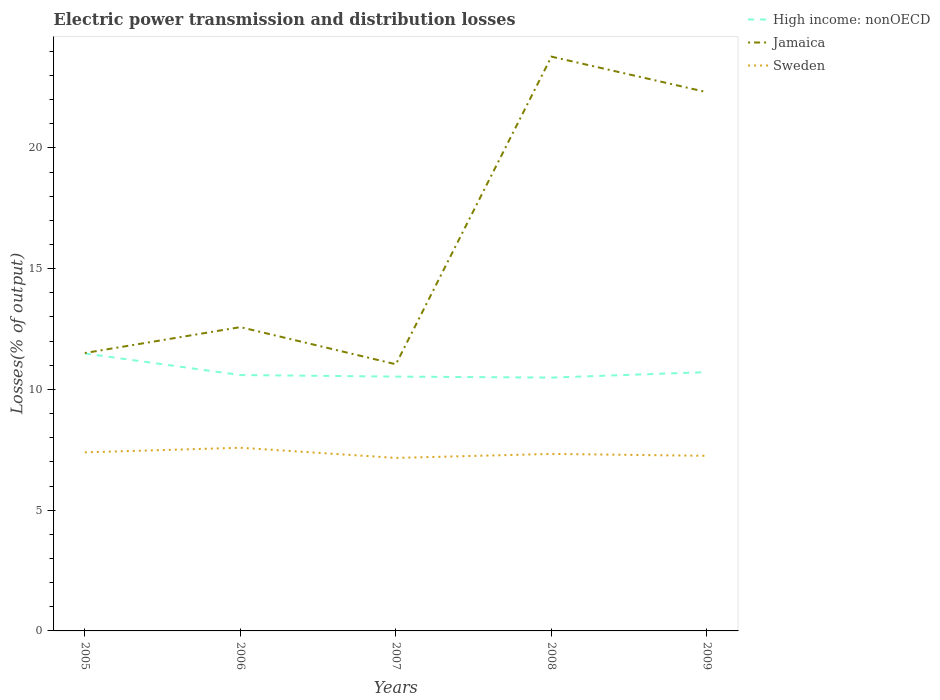How many different coloured lines are there?
Offer a terse response. 3. Across all years, what is the maximum electric power transmission and distribution losses in Sweden?
Provide a short and direct response. 7.16. In which year was the electric power transmission and distribution losses in Sweden maximum?
Provide a succinct answer. 2007. What is the total electric power transmission and distribution losses in Jamaica in the graph?
Give a very brief answer. -9.73. What is the difference between the highest and the second highest electric power transmission and distribution losses in Jamaica?
Offer a very short reply. 12.74. What is the difference between the highest and the lowest electric power transmission and distribution losses in Jamaica?
Your answer should be very brief. 2. Is the electric power transmission and distribution losses in High income: nonOECD strictly greater than the electric power transmission and distribution losses in Jamaica over the years?
Your answer should be compact. Yes. How many lines are there?
Offer a terse response. 3. What is the difference between two consecutive major ticks on the Y-axis?
Give a very brief answer. 5. Are the values on the major ticks of Y-axis written in scientific E-notation?
Offer a terse response. No. Does the graph contain any zero values?
Your answer should be very brief. No. What is the title of the graph?
Your answer should be very brief. Electric power transmission and distribution losses. What is the label or title of the X-axis?
Provide a succinct answer. Years. What is the label or title of the Y-axis?
Offer a very short reply. Losses(% of output). What is the Losses(% of output) of High income: nonOECD in 2005?
Your answer should be compact. 11.49. What is the Losses(% of output) in Jamaica in 2005?
Your answer should be very brief. 11.51. What is the Losses(% of output) of Sweden in 2005?
Ensure brevity in your answer.  7.39. What is the Losses(% of output) of High income: nonOECD in 2006?
Make the answer very short. 10.59. What is the Losses(% of output) of Jamaica in 2006?
Keep it short and to the point. 12.58. What is the Losses(% of output) in Sweden in 2006?
Provide a short and direct response. 7.58. What is the Losses(% of output) of High income: nonOECD in 2007?
Provide a short and direct response. 10.53. What is the Losses(% of output) in Jamaica in 2007?
Ensure brevity in your answer.  11.04. What is the Losses(% of output) in Sweden in 2007?
Provide a short and direct response. 7.16. What is the Losses(% of output) in High income: nonOECD in 2008?
Offer a terse response. 10.49. What is the Losses(% of output) of Jamaica in 2008?
Your answer should be very brief. 23.78. What is the Losses(% of output) of Sweden in 2008?
Provide a short and direct response. 7.33. What is the Losses(% of output) of High income: nonOECD in 2009?
Keep it short and to the point. 10.72. What is the Losses(% of output) of Jamaica in 2009?
Give a very brief answer. 22.31. What is the Losses(% of output) of Sweden in 2009?
Give a very brief answer. 7.25. Across all years, what is the maximum Losses(% of output) in High income: nonOECD?
Give a very brief answer. 11.49. Across all years, what is the maximum Losses(% of output) of Jamaica?
Your answer should be compact. 23.78. Across all years, what is the maximum Losses(% of output) in Sweden?
Make the answer very short. 7.58. Across all years, what is the minimum Losses(% of output) of High income: nonOECD?
Your answer should be compact. 10.49. Across all years, what is the minimum Losses(% of output) of Jamaica?
Give a very brief answer. 11.04. Across all years, what is the minimum Losses(% of output) of Sweden?
Provide a short and direct response. 7.16. What is the total Losses(% of output) of High income: nonOECD in the graph?
Keep it short and to the point. 53.82. What is the total Losses(% of output) in Jamaica in the graph?
Give a very brief answer. 81.21. What is the total Losses(% of output) in Sweden in the graph?
Ensure brevity in your answer.  36.72. What is the difference between the Losses(% of output) in High income: nonOECD in 2005 and that in 2006?
Give a very brief answer. 0.89. What is the difference between the Losses(% of output) in Jamaica in 2005 and that in 2006?
Your answer should be very brief. -1.07. What is the difference between the Losses(% of output) in Sweden in 2005 and that in 2006?
Offer a terse response. -0.19. What is the difference between the Losses(% of output) in High income: nonOECD in 2005 and that in 2007?
Your response must be concise. 0.96. What is the difference between the Losses(% of output) of Jamaica in 2005 and that in 2007?
Give a very brief answer. 0.47. What is the difference between the Losses(% of output) of Sweden in 2005 and that in 2007?
Give a very brief answer. 0.23. What is the difference between the Losses(% of output) in Jamaica in 2005 and that in 2008?
Ensure brevity in your answer.  -12.27. What is the difference between the Losses(% of output) in Sweden in 2005 and that in 2008?
Your answer should be compact. 0.07. What is the difference between the Losses(% of output) of High income: nonOECD in 2005 and that in 2009?
Keep it short and to the point. 0.77. What is the difference between the Losses(% of output) in Jamaica in 2005 and that in 2009?
Keep it short and to the point. -10.8. What is the difference between the Losses(% of output) of Sweden in 2005 and that in 2009?
Keep it short and to the point. 0.14. What is the difference between the Losses(% of output) of High income: nonOECD in 2006 and that in 2007?
Provide a short and direct response. 0.06. What is the difference between the Losses(% of output) in Jamaica in 2006 and that in 2007?
Provide a succinct answer. 1.54. What is the difference between the Losses(% of output) in Sweden in 2006 and that in 2007?
Your answer should be compact. 0.42. What is the difference between the Losses(% of output) of High income: nonOECD in 2006 and that in 2008?
Your answer should be very brief. 0.1. What is the difference between the Losses(% of output) of Jamaica in 2006 and that in 2008?
Ensure brevity in your answer.  -11.2. What is the difference between the Losses(% of output) of Sweden in 2006 and that in 2008?
Ensure brevity in your answer.  0.26. What is the difference between the Losses(% of output) in High income: nonOECD in 2006 and that in 2009?
Ensure brevity in your answer.  -0.12. What is the difference between the Losses(% of output) in Jamaica in 2006 and that in 2009?
Keep it short and to the point. -9.73. What is the difference between the Losses(% of output) of Sweden in 2006 and that in 2009?
Your answer should be very brief. 0.33. What is the difference between the Losses(% of output) in High income: nonOECD in 2007 and that in 2008?
Your response must be concise. 0.04. What is the difference between the Losses(% of output) in Jamaica in 2007 and that in 2008?
Your answer should be compact. -12.74. What is the difference between the Losses(% of output) of Sweden in 2007 and that in 2008?
Keep it short and to the point. -0.17. What is the difference between the Losses(% of output) of High income: nonOECD in 2007 and that in 2009?
Keep it short and to the point. -0.19. What is the difference between the Losses(% of output) of Jamaica in 2007 and that in 2009?
Your response must be concise. -11.26. What is the difference between the Losses(% of output) of Sweden in 2007 and that in 2009?
Provide a succinct answer. -0.09. What is the difference between the Losses(% of output) in High income: nonOECD in 2008 and that in 2009?
Your answer should be very brief. -0.23. What is the difference between the Losses(% of output) of Jamaica in 2008 and that in 2009?
Your answer should be compact. 1.47. What is the difference between the Losses(% of output) of Sweden in 2008 and that in 2009?
Give a very brief answer. 0.08. What is the difference between the Losses(% of output) in High income: nonOECD in 2005 and the Losses(% of output) in Jamaica in 2006?
Your answer should be very brief. -1.09. What is the difference between the Losses(% of output) of High income: nonOECD in 2005 and the Losses(% of output) of Sweden in 2006?
Your response must be concise. 3.9. What is the difference between the Losses(% of output) in Jamaica in 2005 and the Losses(% of output) in Sweden in 2006?
Your response must be concise. 3.92. What is the difference between the Losses(% of output) of High income: nonOECD in 2005 and the Losses(% of output) of Jamaica in 2007?
Your answer should be very brief. 0.45. What is the difference between the Losses(% of output) of High income: nonOECD in 2005 and the Losses(% of output) of Sweden in 2007?
Your answer should be compact. 4.32. What is the difference between the Losses(% of output) in Jamaica in 2005 and the Losses(% of output) in Sweden in 2007?
Offer a terse response. 4.34. What is the difference between the Losses(% of output) in High income: nonOECD in 2005 and the Losses(% of output) in Jamaica in 2008?
Your answer should be compact. -12.29. What is the difference between the Losses(% of output) in High income: nonOECD in 2005 and the Losses(% of output) in Sweden in 2008?
Offer a very short reply. 4.16. What is the difference between the Losses(% of output) of Jamaica in 2005 and the Losses(% of output) of Sweden in 2008?
Give a very brief answer. 4.18. What is the difference between the Losses(% of output) of High income: nonOECD in 2005 and the Losses(% of output) of Jamaica in 2009?
Provide a short and direct response. -10.82. What is the difference between the Losses(% of output) of High income: nonOECD in 2005 and the Losses(% of output) of Sweden in 2009?
Keep it short and to the point. 4.24. What is the difference between the Losses(% of output) in Jamaica in 2005 and the Losses(% of output) in Sweden in 2009?
Your response must be concise. 4.26. What is the difference between the Losses(% of output) in High income: nonOECD in 2006 and the Losses(% of output) in Jamaica in 2007?
Provide a short and direct response. -0.45. What is the difference between the Losses(% of output) in High income: nonOECD in 2006 and the Losses(% of output) in Sweden in 2007?
Keep it short and to the point. 3.43. What is the difference between the Losses(% of output) in Jamaica in 2006 and the Losses(% of output) in Sweden in 2007?
Provide a succinct answer. 5.42. What is the difference between the Losses(% of output) of High income: nonOECD in 2006 and the Losses(% of output) of Jamaica in 2008?
Your response must be concise. -13.18. What is the difference between the Losses(% of output) in High income: nonOECD in 2006 and the Losses(% of output) in Sweden in 2008?
Give a very brief answer. 3.27. What is the difference between the Losses(% of output) of Jamaica in 2006 and the Losses(% of output) of Sweden in 2008?
Ensure brevity in your answer.  5.25. What is the difference between the Losses(% of output) of High income: nonOECD in 2006 and the Losses(% of output) of Jamaica in 2009?
Provide a short and direct response. -11.71. What is the difference between the Losses(% of output) in High income: nonOECD in 2006 and the Losses(% of output) in Sweden in 2009?
Your answer should be very brief. 3.34. What is the difference between the Losses(% of output) in Jamaica in 2006 and the Losses(% of output) in Sweden in 2009?
Your answer should be compact. 5.33. What is the difference between the Losses(% of output) in High income: nonOECD in 2007 and the Losses(% of output) in Jamaica in 2008?
Offer a very short reply. -13.25. What is the difference between the Losses(% of output) of High income: nonOECD in 2007 and the Losses(% of output) of Sweden in 2008?
Your response must be concise. 3.2. What is the difference between the Losses(% of output) of Jamaica in 2007 and the Losses(% of output) of Sweden in 2008?
Provide a short and direct response. 3.71. What is the difference between the Losses(% of output) of High income: nonOECD in 2007 and the Losses(% of output) of Jamaica in 2009?
Offer a terse response. -11.78. What is the difference between the Losses(% of output) in High income: nonOECD in 2007 and the Losses(% of output) in Sweden in 2009?
Offer a terse response. 3.28. What is the difference between the Losses(% of output) in Jamaica in 2007 and the Losses(% of output) in Sweden in 2009?
Provide a short and direct response. 3.79. What is the difference between the Losses(% of output) in High income: nonOECD in 2008 and the Losses(% of output) in Jamaica in 2009?
Keep it short and to the point. -11.82. What is the difference between the Losses(% of output) of High income: nonOECD in 2008 and the Losses(% of output) of Sweden in 2009?
Your answer should be compact. 3.24. What is the difference between the Losses(% of output) of Jamaica in 2008 and the Losses(% of output) of Sweden in 2009?
Your answer should be very brief. 16.53. What is the average Losses(% of output) of High income: nonOECD per year?
Your answer should be compact. 10.76. What is the average Losses(% of output) of Jamaica per year?
Your answer should be compact. 16.24. What is the average Losses(% of output) of Sweden per year?
Ensure brevity in your answer.  7.34. In the year 2005, what is the difference between the Losses(% of output) of High income: nonOECD and Losses(% of output) of Jamaica?
Provide a succinct answer. -0.02. In the year 2005, what is the difference between the Losses(% of output) in High income: nonOECD and Losses(% of output) in Sweden?
Give a very brief answer. 4.09. In the year 2005, what is the difference between the Losses(% of output) in Jamaica and Losses(% of output) in Sweden?
Make the answer very short. 4.11. In the year 2006, what is the difference between the Losses(% of output) of High income: nonOECD and Losses(% of output) of Jamaica?
Your response must be concise. -1.98. In the year 2006, what is the difference between the Losses(% of output) of High income: nonOECD and Losses(% of output) of Sweden?
Offer a terse response. 3.01. In the year 2006, what is the difference between the Losses(% of output) of Jamaica and Losses(% of output) of Sweden?
Give a very brief answer. 4.99. In the year 2007, what is the difference between the Losses(% of output) of High income: nonOECD and Losses(% of output) of Jamaica?
Offer a very short reply. -0.51. In the year 2007, what is the difference between the Losses(% of output) of High income: nonOECD and Losses(% of output) of Sweden?
Keep it short and to the point. 3.37. In the year 2007, what is the difference between the Losses(% of output) of Jamaica and Losses(% of output) of Sweden?
Provide a succinct answer. 3.88. In the year 2008, what is the difference between the Losses(% of output) of High income: nonOECD and Losses(% of output) of Jamaica?
Your answer should be very brief. -13.29. In the year 2008, what is the difference between the Losses(% of output) in High income: nonOECD and Losses(% of output) in Sweden?
Your response must be concise. 3.16. In the year 2008, what is the difference between the Losses(% of output) in Jamaica and Losses(% of output) in Sweden?
Give a very brief answer. 16.45. In the year 2009, what is the difference between the Losses(% of output) of High income: nonOECD and Losses(% of output) of Jamaica?
Keep it short and to the point. -11.59. In the year 2009, what is the difference between the Losses(% of output) of High income: nonOECD and Losses(% of output) of Sweden?
Your answer should be very brief. 3.46. In the year 2009, what is the difference between the Losses(% of output) in Jamaica and Losses(% of output) in Sweden?
Your answer should be compact. 15.05. What is the ratio of the Losses(% of output) of High income: nonOECD in 2005 to that in 2006?
Your answer should be compact. 1.08. What is the ratio of the Losses(% of output) of Jamaica in 2005 to that in 2006?
Provide a succinct answer. 0.91. What is the ratio of the Losses(% of output) of Sweden in 2005 to that in 2006?
Offer a terse response. 0.97. What is the ratio of the Losses(% of output) of High income: nonOECD in 2005 to that in 2007?
Give a very brief answer. 1.09. What is the ratio of the Losses(% of output) of Jamaica in 2005 to that in 2007?
Your response must be concise. 1.04. What is the ratio of the Losses(% of output) in Sweden in 2005 to that in 2007?
Your answer should be compact. 1.03. What is the ratio of the Losses(% of output) of High income: nonOECD in 2005 to that in 2008?
Offer a very short reply. 1.1. What is the ratio of the Losses(% of output) of Jamaica in 2005 to that in 2008?
Your response must be concise. 0.48. What is the ratio of the Losses(% of output) in Sweden in 2005 to that in 2008?
Ensure brevity in your answer.  1.01. What is the ratio of the Losses(% of output) of High income: nonOECD in 2005 to that in 2009?
Give a very brief answer. 1.07. What is the ratio of the Losses(% of output) in Jamaica in 2005 to that in 2009?
Ensure brevity in your answer.  0.52. What is the ratio of the Losses(% of output) of Sweden in 2005 to that in 2009?
Your response must be concise. 1.02. What is the ratio of the Losses(% of output) in Jamaica in 2006 to that in 2007?
Give a very brief answer. 1.14. What is the ratio of the Losses(% of output) in Sweden in 2006 to that in 2007?
Make the answer very short. 1.06. What is the ratio of the Losses(% of output) of High income: nonOECD in 2006 to that in 2008?
Your answer should be very brief. 1.01. What is the ratio of the Losses(% of output) in Jamaica in 2006 to that in 2008?
Your response must be concise. 0.53. What is the ratio of the Losses(% of output) in Sweden in 2006 to that in 2008?
Your response must be concise. 1.03. What is the ratio of the Losses(% of output) in Jamaica in 2006 to that in 2009?
Ensure brevity in your answer.  0.56. What is the ratio of the Losses(% of output) of Sweden in 2006 to that in 2009?
Offer a very short reply. 1.05. What is the ratio of the Losses(% of output) in Jamaica in 2007 to that in 2008?
Give a very brief answer. 0.46. What is the ratio of the Losses(% of output) in Sweden in 2007 to that in 2008?
Ensure brevity in your answer.  0.98. What is the ratio of the Losses(% of output) in High income: nonOECD in 2007 to that in 2009?
Keep it short and to the point. 0.98. What is the ratio of the Losses(% of output) in Jamaica in 2007 to that in 2009?
Give a very brief answer. 0.49. What is the ratio of the Losses(% of output) of Sweden in 2007 to that in 2009?
Provide a succinct answer. 0.99. What is the ratio of the Losses(% of output) of High income: nonOECD in 2008 to that in 2009?
Offer a terse response. 0.98. What is the ratio of the Losses(% of output) of Jamaica in 2008 to that in 2009?
Offer a very short reply. 1.07. What is the ratio of the Losses(% of output) in Sweden in 2008 to that in 2009?
Offer a terse response. 1.01. What is the difference between the highest and the second highest Losses(% of output) in High income: nonOECD?
Offer a terse response. 0.77. What is the difference between the highest and the second highest Losses(% of output) of Jamaica?
Your answer should be very brief. 1.47. What is the difference between the highest and the second highest Losses(% of output) in Sweden?
Make the answer very short. 0.19. What is the difference between the highest and the lowest Losses(% of output) in Jamaica?
Provide a short and direct response. 12.74. What is the difference between the highest and the lowest Losses(% of output) in Sweden?
Make the answer very short. 0.42. 